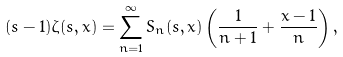Convert formula to latex. <formula><loc_0><loc_0><loc_500><loc_500>( s - 1 ) \zeta ( s , x ) = \sum _ { n = 1 } ^ { \infty } S _ { n } ( s , x ) \left ( \frac { 1 } { n + 1 } + \frac { x - 1 } { n } \right ) ,</formula> 